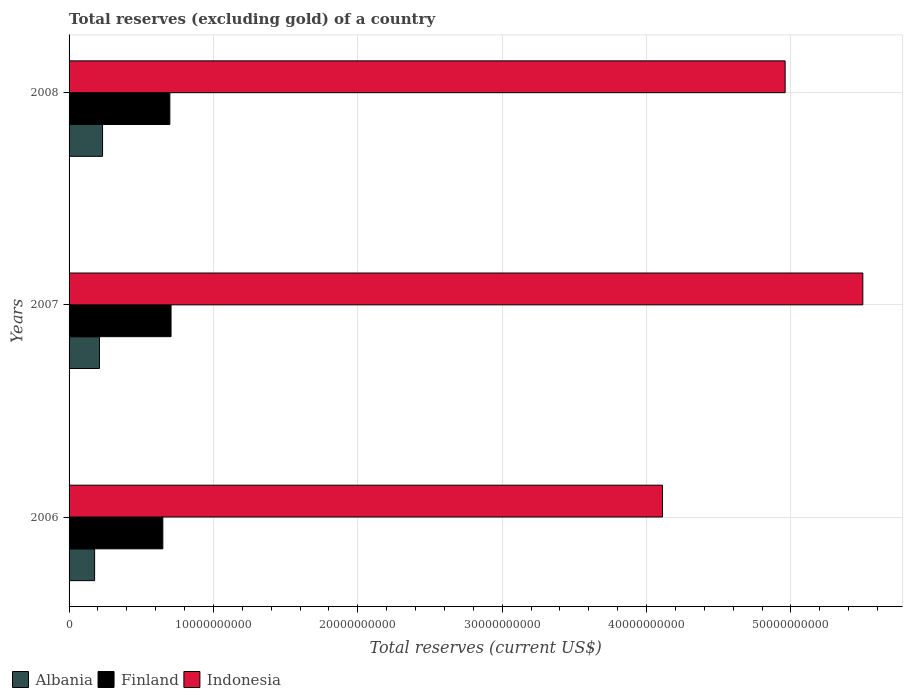How many groups of bars are there?
Ensure brevity in your answer.  3. What is the label of the 1st group of bars from the top?
Your answer should be very brief. 2008. What is the total reserves (excluding gold) in Finland in 2008?
Provide a succinct answer. 6.98e+09. Across all years, what is the maximum total reserves (excluding gold) in Albania?
Give a very brief answer. 2.32e+09. Across all years, what is the minimum total reserves (excluding gold) in Albania?
Offer a very short reply. 1.77e+09. In which year was the total reserves (excluding gold) in Indonesia maximum?
Provide a short and direct response. 2007. What is the total total reserves (excluding gold) in Indonesia in the graph?
Ensure brevity in your answer.  1.46e+11. What is the difference between the total reserves (excluding gold) in Albania in 2006 and that in 2008?
Provide a succinct answer. -5.51e+08. What is the difference between the total reserves (excluding gold) in Indonesia in 2006 and the total reserves (excluding gold) in Albania in 2007?
Offer a very short reply. 3.90e+1. What is the average total reserves (excluding gold) in Finland per year?
Give a very brief answer. 6.85e+09. In the year 2008, what is the difference between the total reserves (excluding gold) in Albania and total reserves (excluding gold) in Indonesia?
Your answer should be very brief. -4.73e+1. What is the ratio of the total reserves (excluding gold) in Albania in 2006 to that in 2007?
Provide a short and direct response. 0.84. Is the total reserves (excluding gold) in Albania in 2007 less than that in 2008?
Your answer should be compact. Yes. What is the difference between the highest and the second highest total reserves (excluding gold) in Indonesia?
Your answer should be very brief. 5.38e+09. What is the difference between the highest and the lowest total reserves (excluding gold) in Indonesia?
Give a very brief answer. 1.39e+1. In how many years, is the total reserves (excluding gold) in Finland greater than the average total reserves (excluding gold) in Finland taken over all years?
Keep it short and to the point. 2. Is the sum of the total reserves (excluding gold) in Finland in 2006 and 2008 greater than the maximum total reserves (excluding gold) in Indonesia across all years?
Offer a very short reply. No. What does the 3rd bar from the bottom in 2007 represents?
Your answer should be very brief. Indonesia. Is it the case that in every year, the sum of the total reserves (excluding gold) in Indonesia and total reserves (excluding gold) in Albania is greater than the total reserves (excluding gold) in Finland?
Your response must be concise. Yes. Are all the bars in the graph horizontal?
Provide a short and direct response. Yes. What is the difference between two consecutive major ticks on the X-axis?
Offer a terse response. 1.00e+1. Are the values on the major ticks of X-axis written in scientific E-notation?
Provide a short and direct response. No. Does the graph contain any zero values?
Provide a succinct answer. No. Where does the legend appear in the graph?
Provide a succinct answer. Bottom left. How many legend labels are there?
Give a very brief answer. 3. How are the legend labels stacked?
Your response must be concise. Horizontal. What is the title of the graph?
Ensure brevity in your answer.  Total reserves (excluding gold) of a country. Does "Austria" appear as one of the legend labels in the graph?
Offer a very short reply. No. What is the label or title of the X-axis?
Ensure brevity in your answer.  Total reserves (current US$). What is the label or title of the Y-axis?
Make the answer very short. Years. What is the Total reserves (current US$) of Albania in 2006?
Make the answer very short. 1.77e+09. What is the Total reserves (current US$) in Finland in 2006?
Your answer should be very brief. 6.49e+09. What is the Total reserves (current US$) in Indonesia in 2006?
Your response must be concise. 4.11e+1. What is the Total reserves (current US$) in Albania in 2007?
Your response must be concise. 2.10e+09. What is the Total reserves (current US$) of Finland in 2007?
Your response must be concise. 7.06e+09. What is the Total reserves (current US$) of Indonesia in 2007?
Provide a short and direct response. 5.50e+1. What is the Total reserves (current US$) in Albania in 2008?
Give a very brief answer. 2.32e+09. What is the Total reserves (current US$) in Finland in 2008?
Your response must be concise. 6.98e+09. What is the Total reserves (current US$) in Indonesia in 2008?
Keep it short and to the point. 4.96e+1. Across all years, what is the maximum Total reserves (current US$) of Albania?
Ensure brevity in your answer.  2.32e+09. Across all years, what is the maximum Total reserves (current US$) of Finland?
Your response must be concise. 7.06e+09. Across all years, what is the maximum Total reserves (current US$) in Indonesia?
Provide a short and direct response. 5.50e+1. Across all years, what is the minimum Total reserves (current US$) in Albania?
Make the answer very short. 1.77e+09. Across all years, what is the minimum Total reserves (current US$) in Finland?
Your answer should be very brief. 6.49e+09. Across all years, what is the minimum Total reserves (current US$) in Indonesia?
Offer a terse response. 4.11e+1. What is the total Total reserves (current US$) in Albania in the graph?
Your answer should be compact. 6.19e+09. What is the total Total reserves (current US$) in Finland in the graph?
Your answer should be compact. 2.05e+1. What is the total Total reserves (current US$) in Indonesia in the graph?
Your response must be concise. 1.46e+11. What is the difference between the Total reserves (current US$) in Albania in 2006 and that in 2007?
Offer a very short reply. -3.35e+08. What is the difference between the Total reserves (current US$) in Finland in 2006 and that in 2007?
Provide a short and direct response. -5.69e+08. What is the difference between the Total reserves (current US$) in Indonesia in 2006 and that in 2007?
Give a very brief answer. -1.39e+1. What is the difference between the Total reserves (current US$) of Albania in 2006 and that in 2008?
Your response must be concise. -5.51e+08. What is the difference between the Total reserves (current US$) in Finland in 2006 and that in 2008?
Your response must be concise. -4.85e+08. What is the difference between the Total reserves (current US$) of Indonesia in 2006 and that in 2008?
Ensure brevity in your answer.  -8.49e+09. What is the difference between the Total reserves (current US$) of Albania in 2007 and that in 2008?
Offer a terse response. -2.16e+08. What is the difference between the Total reserves (current US$) in Finland in 2007 and that in 2008?
Provide a short and direct response. 8.38e+07. What is the difference between the Total reserves (current US$) in Indonesia in 2007 and that in 2008?
Your answer should be very brief. 5.38e+09. What is the difference between the Total reserves (current US$) in Albania in 2006 and the Total reserves (current US$) in Finland in 2007?
Your answer should be compact. -5.29e+09. What is the difference between the Total reserves (current US$) of Albania in 2006 and the Total reserves (current US$) of Indonesia in 2007?
Keep it short and to the point. -5.32e+1. What is the difference between the Total reserves (current US$) of Finland in 2006 and the Total reserves (current US$) of Indonesia in 2007?
Ensure brevity in your answer.  -4.85e+1. What is the difference between the Total reserves (current US$) in Albania in 2006 and the Total reserves (current US$) in Finland in 2008?
Make the answer very short. -5.21e+09. What is the difference between the Total reserves (current US$) in Albania in 2006 and the Total reserves (current US$) in Indonesia in 2008?
Give a very brief answer. -4.78e+1. What is the difference between the Total reserves (current US$) in Finland in 2006 and the Total reserves (current US$) in Indonesia in 2008?
Give a very brief answer. -4.31e+1. What is the difference between the Total reserves (current US$) in Albania in 2007 and the Total reserves (current US$) in Finland in 2008?
Offer a very short reply. -4.88e+09. What is the difference between the Total reserves (current US$) of Albania in 2007 and the Total reserves (current US$) of Indonesia in 2008?
Provide a short and direct response. -4.75e+1. What is the difference between the Total reserves (current US$) in Finland in 2007 and the Total reserves (current US$) in Indonesia in 2008?
Your answer should be compact. -4.25e+1. What is the average Total reserves (current US$) in Albania per year?
Provide a short and direct response. 2.06e+09. What is the average Total reserves (current US$) in Finland per year?
Keep it short and to the point. 6.85e+09. What is the average Total reserves (current US$) of Indonesia per year?
Ensure brevity in your answer.  4.86e+1. In the year 2006, what is the difference between the Total reserves (current US$) in Albania and Total reserves (current US$) in Finland?
Make the answer very short. -4.73e+09. In the year 2006, what is the difference between the Total reserves (current US$) in Albania and Total reserves (current US$) in Indonesia?
Offer a terse response. -3.93e+1. In the year 2006, what is the difference between the Total reserves (current US$) of Finland and Total reserves (current US$) of Indonesia?
Your response must be concise. -3.46e+1. In the year 2007, what is the difference between the Total reserves (current US$) of Albania and Total reserves (current US$) of Finland?
Ensure brevity in your answer.  -4.96e+09. In the year 2007, what is the difference between the Total reserves (current US$) in Albania and Total reserves (current US$) in Indonesia?
Offer a very short reply. -5.29e+1. In the year 2007, what is the difference between the Total reserves (current US$) in Finland and Total reserves (current US$) in Indonesia?
Provide a succinct answer. -4.79e+1. In the year 2008, what is the difference between the Total reserves (current US$) of Albania and Total reserves (current US$) of Finland?
Offer a terse response. -4.66e+09. In the year 2008, what is the difference between the Total reserves (current US$) of Albania and Total reserves (current US$) of Indonesia?
Your answer should be very brief. -4.73e+1. In the year 2008, what is the difference between the Total reserves (current US$) of Finland and Total reserves (current US$) of Indonesia?
Keep it short and to the point. -4.26e+1. What is the ratio of the Total reserves (current US$) of Albania in 2006 to that in 2007?
Provide a short and direct response. 0.84. What is the ratio of the Total reserves (current US$) of Finland in 2006 to that in 2007?
Your answer should be compact. 0.92. What is the ratio of the Total reserves (current US$) in Indonesia in 2006 to that in 2007?
Make the answer very short. 0.75. What is the ratio of the Total reserves (current US$) of Albania in 2006 to that in 2008?
Provide a succinct answer. 0.76. What is the ratio of the Total reserves (current US$) of Finland in 2006 to that in 2008?
Ensure brevity in your answer.  0.93. What is the ratio of the Total reserves (current US$) in Indonesia in 2006 to that in 2008?
Your answer should be compact. 0.83. What is the ratio of the Total reserves (current US$) in Albania in 2007 to that in 2008?
Ensure brevity in your answer.  0.91. What is the ratio of the Total reserves (current US$) of Indonesia in 2007 to that in 2008?
Ensure brevity in your answer.  1.11. What is the difference between the highest and the second highest Total reserves (current US$) in Albania?
Your answer should be very brief. 2.16e+08. What is the difference between the highest and the second highest Total reserves (current US$) in Finland?
Make the answer very short. 8.38e+07. What is the difference between the highest and the second highest Total reserves (current US$) of Indonesia?
Make the answer very short. 5.38e+09. What is the difference between the highest and the lowest Total reserves (current US$) of Albania?
Ensure brevity in your answer.  5.51e+08. What is the difference between the highest and the lowest Total reserves (current US$) of Finland?
Offer a terse response. 5.69e+08. What is the difference between the highest and the lowest Total reserves (current US$) in Indonesia?
Your answer should be compact. 1.39e+1. 